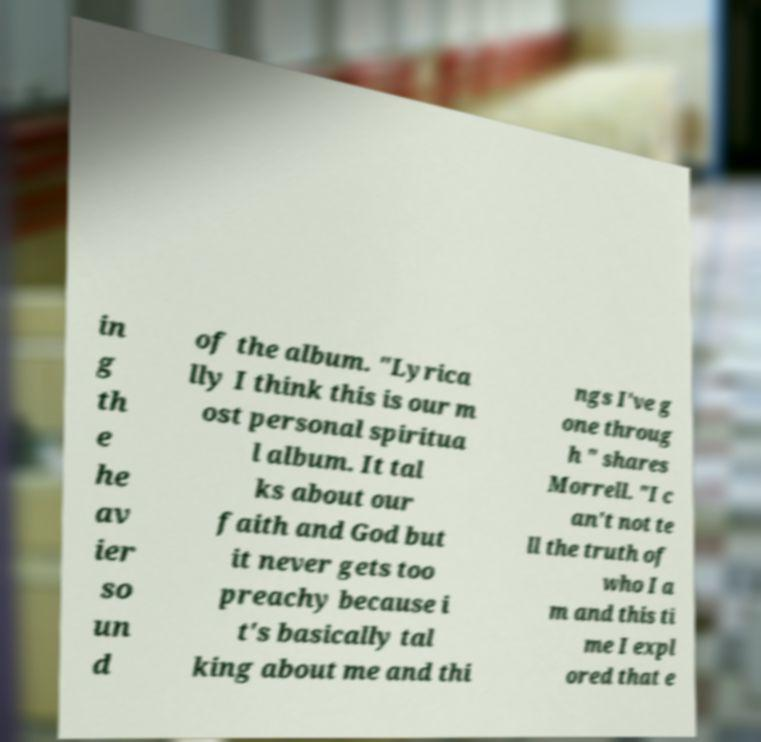Could you assist in decoding the text presented in this image and type it out clearly? in g th e he av ier so un d of the album. "Lyrica lly I think this is our m ost personal spiritua l album. It tal ks about our faith and God but it never gets too preachy because i t's basically tal king about me and thi ngs I've g one throug h " shares Morrell. "I c an't not te ll the truth of who I a m and this ti me I expl ored that e 